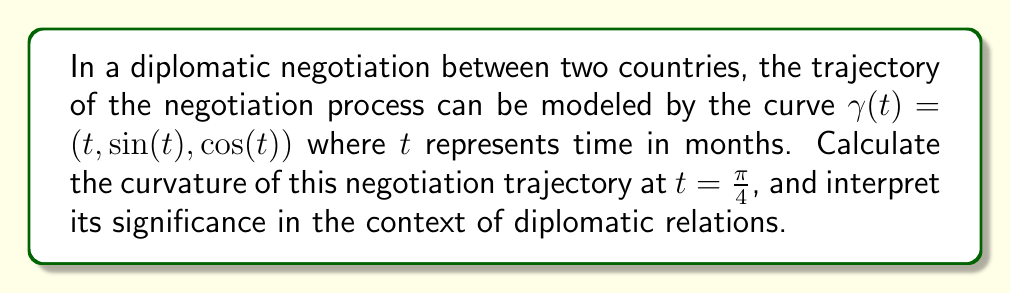Solve this math problem. To solve this problem, we'll use the formula for the curvature of a space curve:

$$\kappa = \frac{|\gamma'(t) \times \gamma''(t)|}{|\gamma'(t)|^3}$$

Step 1: Calculate $\gamma'(t)$ and $\gamma''(t)$
$\gamma'(t) = (1, \cos(t), -\sin(t))$
$\gamma''(t) = (0, -\sin(t), -\cos(t))$

Step 2: Calculate the cross product $\gamma'(t) \times \gamma''(t)$
$$\gamma'(t) \times \gamma''(t) = \begin{vmatrix} 
\mathbf{i} & \mathbf{j} & \mathbf{k} \\
1 & \cos(t) & -\sin(t) \\
0 & -\sin(t) & -\cos(t)
\end{vmatrix}$$

$$= (-\cos^2(t) - \sin^2(t))\mathbf{i} + (-\sin(t))\mathbf{j} + (\cos(t))\mathbf{k}$$

$$= -\mathbf{i} - \sin(t)\mathbf{j} + \cos(t)\mathbf{k}$$

Step 3: Calculate $|\gamma'(t) \times \gamma''(t)|$
$$|\gamma'(t) \times \gamma''(t)| = \sqrt{1^2 + \sin^2(t) + \cos^2(t)} = \sqrt{2}$$

Step 4: Calculate $|\gamma'(t)|$
$$|\gamma'(t)| = \sqrt{1^2 + \cos^2(t) + \sin^2(t)} = \sqrt{2}$$

Step 5: Apply the curvature formula at $t = \frac{\pi}{4}$
$$\kappa(\frac{\pi}{4}) = \frac{|\gamma'(\frac{\pi}{4}) \times \gamma''(\frac{\pi}{4})|}{|\gamma'(\frac{\pi}{4})|^3} = \frac{\sqrt{2}}{(\sqrt{2})^3} = \frac{1}{2}$$

Interpretation: The curvature of 0.5 at $t = \frac{\pi}{4}$ indicates a moderate rate of change in the direction of the negotiation trajectory. In diplomatic terms, this suggests that the negotiation process is neither completely linear (which would have a curvature of 0) nor extremely volatile (which would have a higher curvature). A moderate curvature implies that the diplomatic relations are evolving steadily, with some flexibility but without drastic changes in direction.
Answer: The curvature of the diplomatic negotiation trajectory at $t = \frac{\pi}{4}$ is $\kappa = \frac{1}{2}$. 